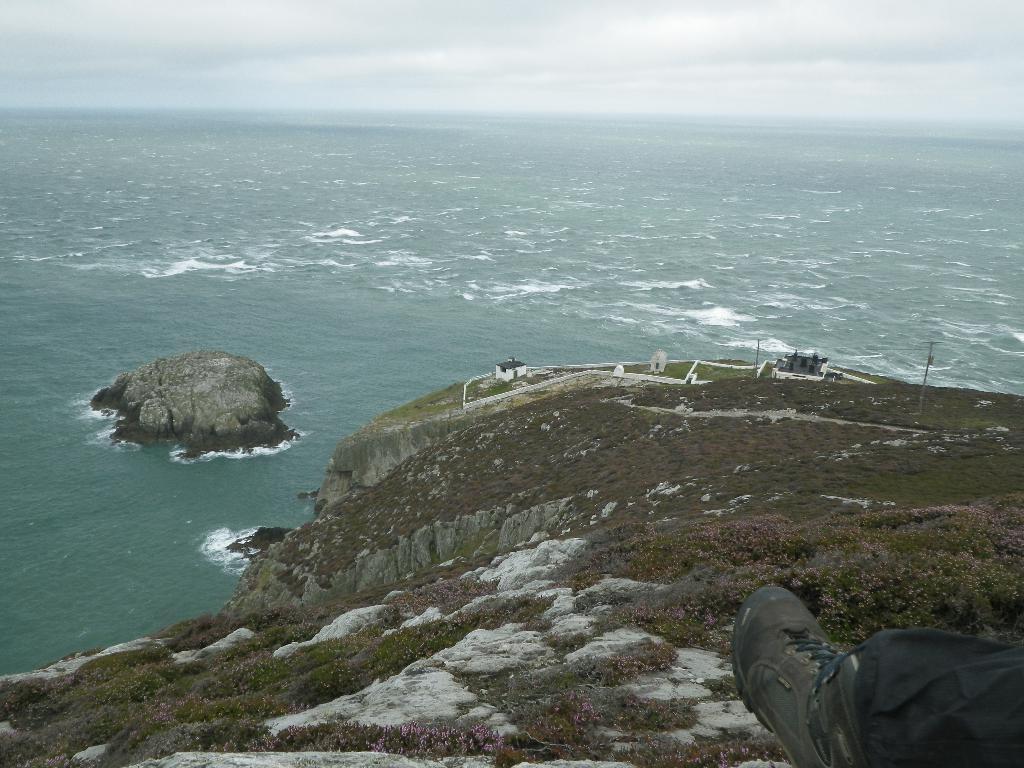How would you summarize this image in a sentence or two? In the image in the center, we can see the sky, clouds, water, hills, grass, poles, buildings and one shoe. 